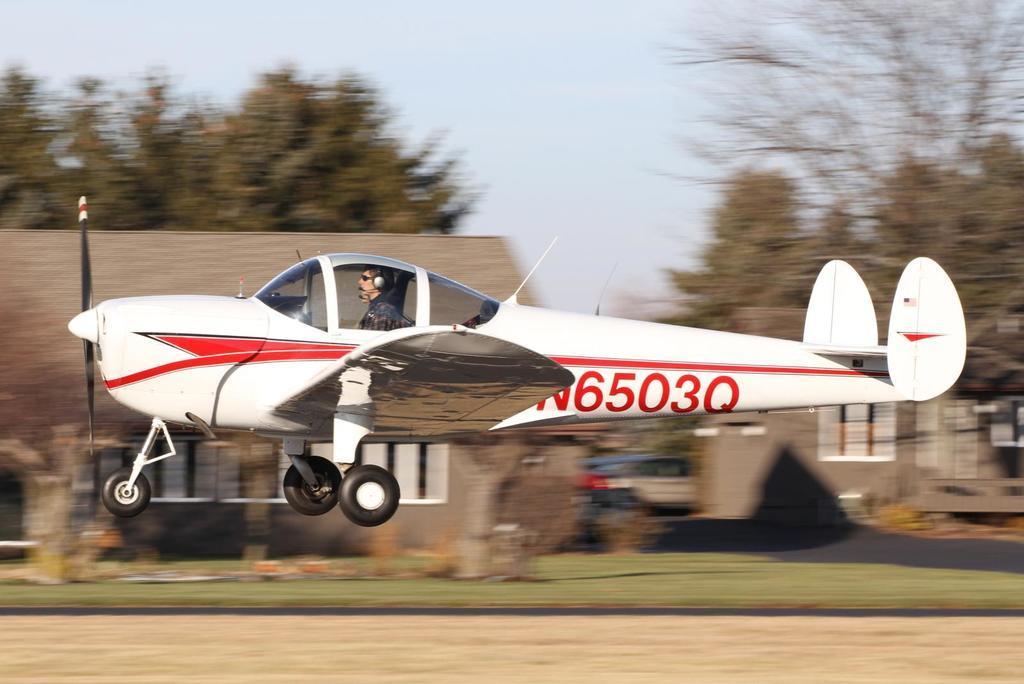In one or two sentences, can you explain what this image depicts? In this image we can see a person wearing headphone is sitting inside an airplane. In the background, we can see a group of buildings, some vehicles, group of trees and sky. 